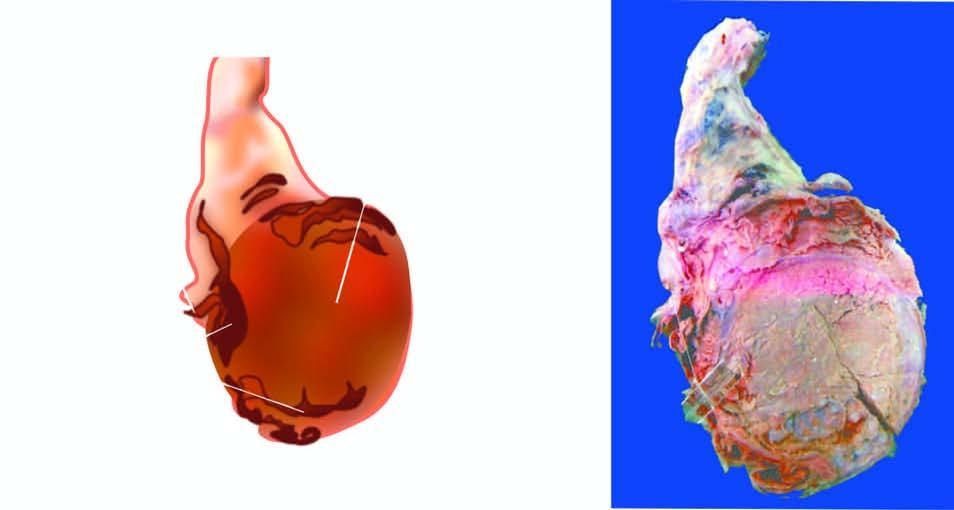what does sectioned surface show?
Answer the question using a single word or phrase. Replacement of the entire testis by variegated mass having grey-white solid areas 